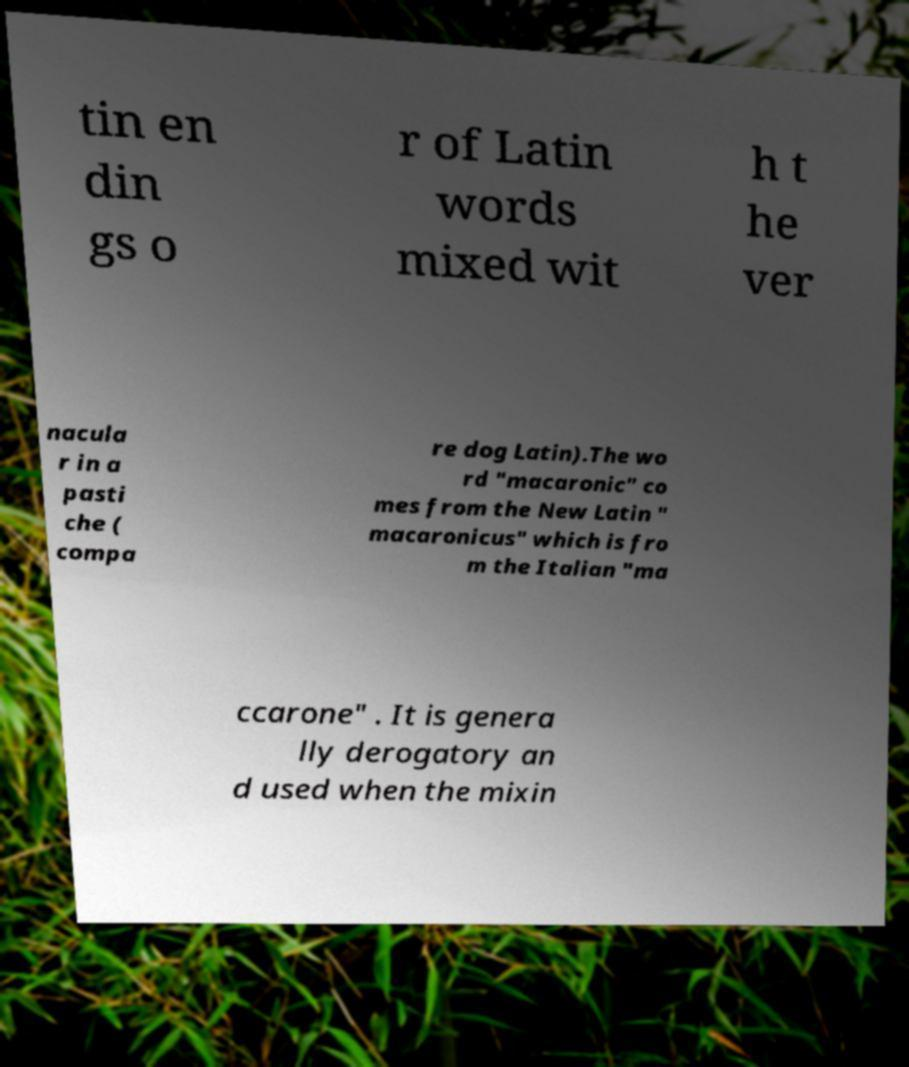Could you extract and type out the text from this image? tin en din gs o r of Latin words mixed wit h t he ver nacula r in a pasti che ( compa re dog Latin).The wo rd "macaronic" co mes from the New Latin " macaronicus" which is fro m the Italian "ma ccarone" . It is genera lly derogatory an d used when the mixin 